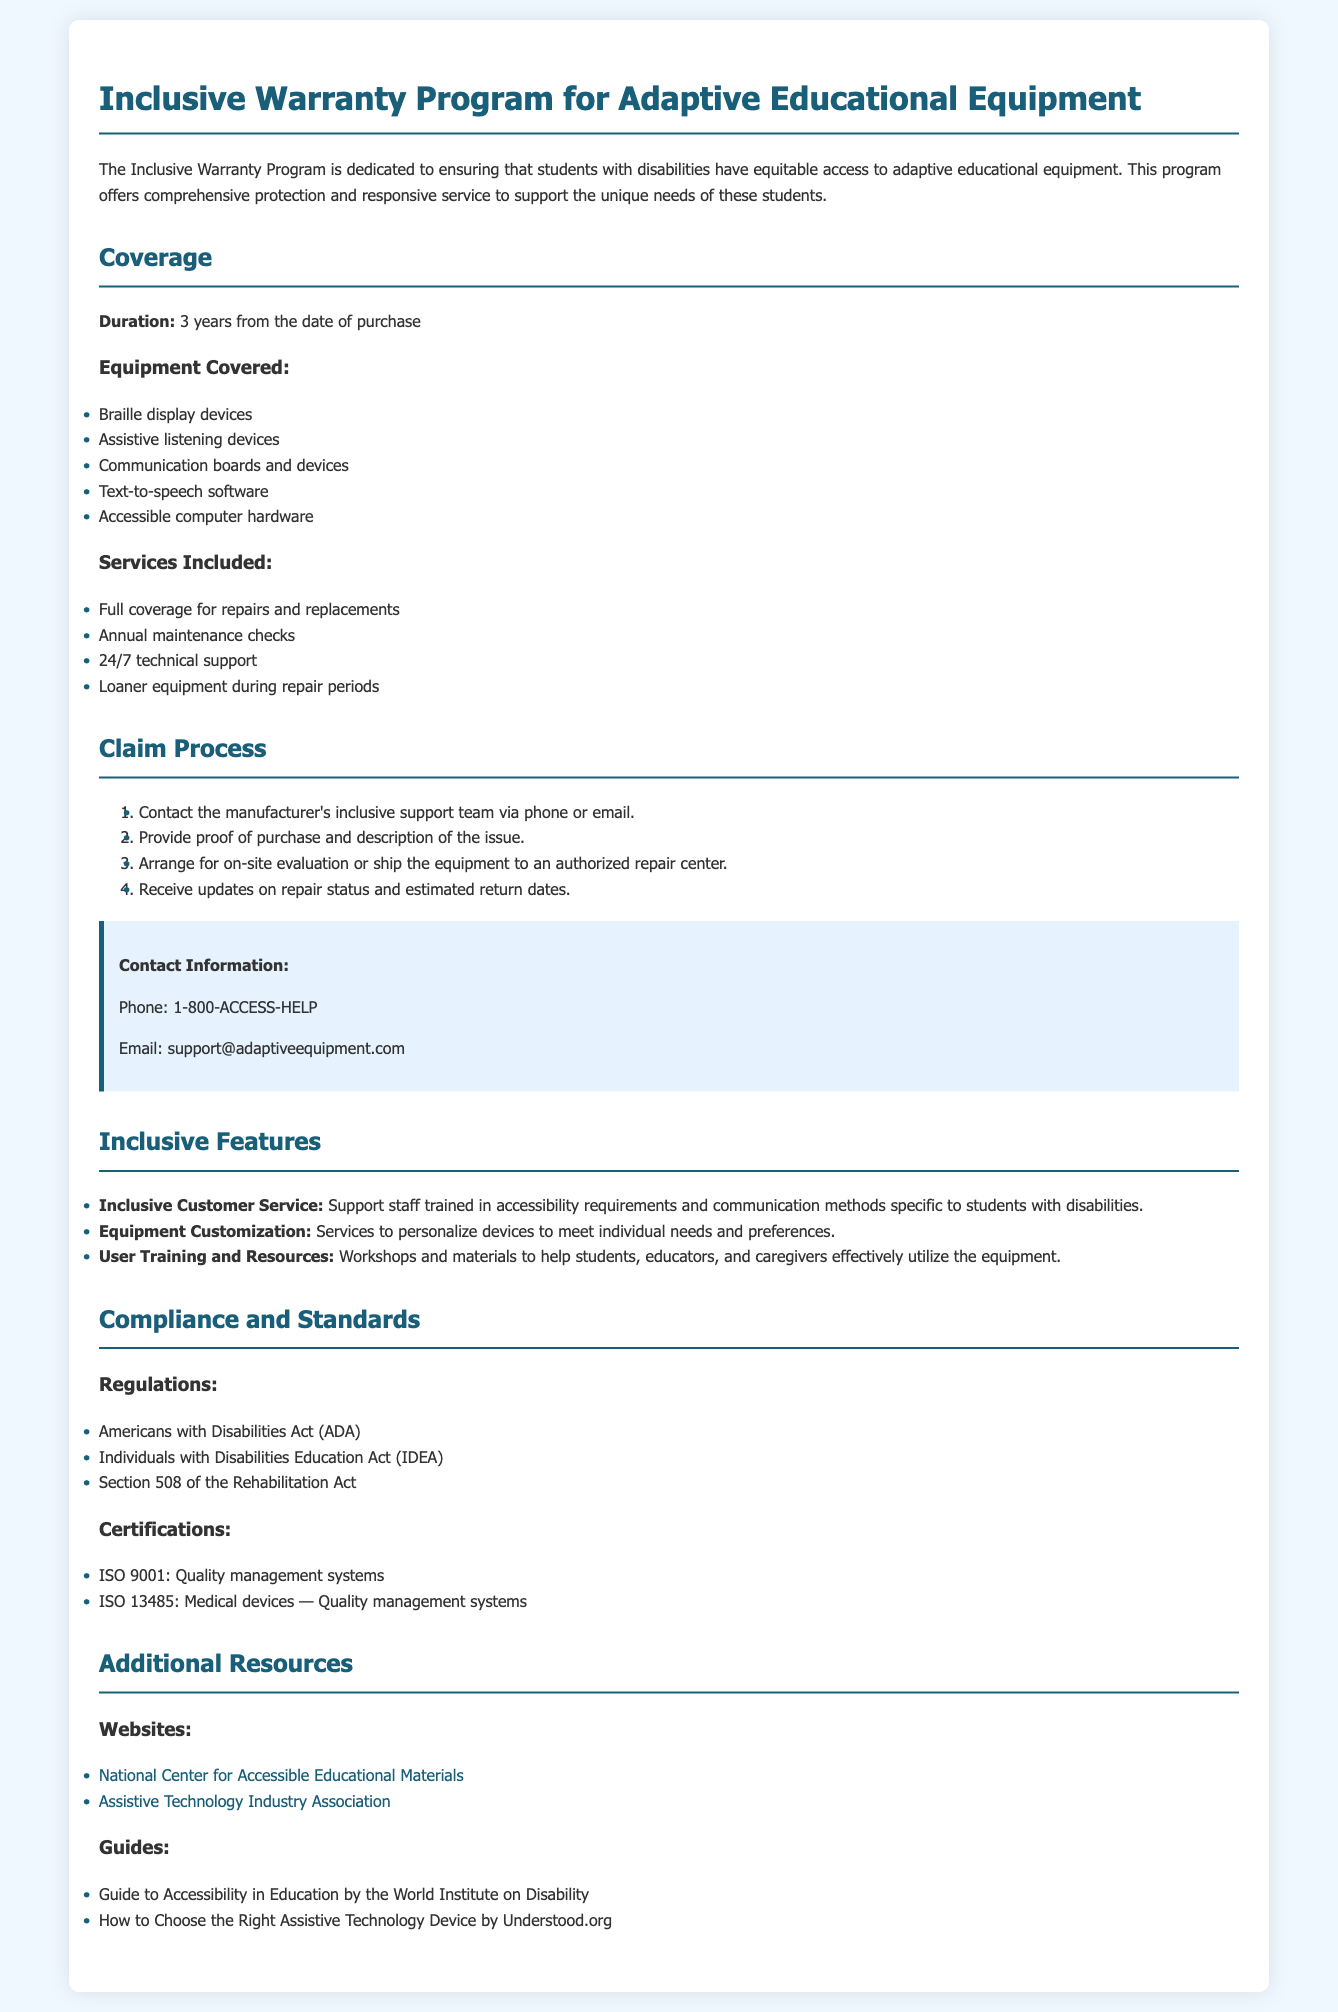what is the duration of the warranty? The duration of the warranty is mentioned as "3 years from the date of purchase."
Answer: 3 years what type of devices are covered under this warranty? The document lists several types of devices, including "Braille display devices," "Assistive listening devices," and more.
Answer: Braille display devices, Assistive listening devices, Communication boards and devices, Text-to-speech software, Accessible computer hardware how many services are included in the warranty? The document outlines four services included in the warranty, indicating a comprehensive program.
Answer: 4 what is the first step in the claim process? The first step in the claim process is to "Contact the manufacturer's inclusive support team via phone or email."
Answer: Contact the manufacturer's inclusive support team which act ensures compliance in this warranty program? The document lists multiple acts, including the "Americans with Disabilities Act (ADA)," as a key compliance regulation.
Answer: Americans with Disabilities Act (ADA) what type of support is provided under inclusive features? One of the inclusive features is "Inclusive Customer Service," which emphasizes accessibility and communication methods.
Answer: Inclusive Customer Service how can one reach the support team? Contact information indicates that one can reach the support team via phone or email, with specific contact details provided.
Answer: Phone: 1-800-ACCESS-HELP, Email: support@adaptiveequipment.com what is the website of the National Center for Accessible Educational Materials? The document provides a URL for the organization, which is essential for accessing additional resources.
Answer: http://aem.cast.org/ what is the coverage for repairs under this warranty? The document states "Full coverage for repairs and replacements" as part of the services included in the warranty.
Answer: Full coverage for repairs and replacements 